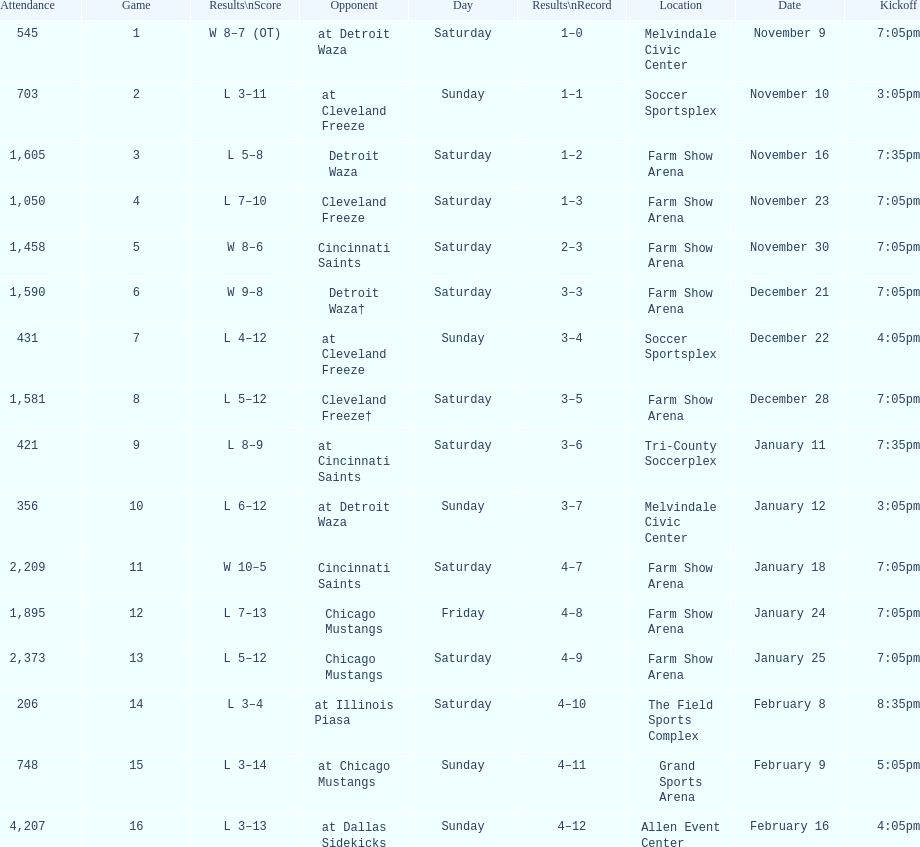How many times did the team play at home but did not win? 5. 